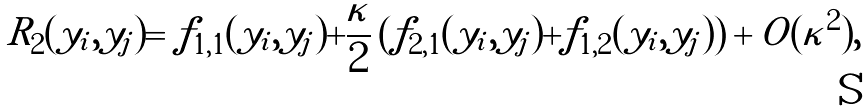Convert formula to latex. <formula><loc_0><loc_0><loc_500><loc_500>R _ { 2 } ( y _ { i } , y _ { j } ) = f _ { 1 , 1 } ( y _ { i } , y _ { j } ) + { \frac { \kappa } { 2 } } \left ( f _ { 2 , 1 } ( y _ { i } , y _ { j } ) + f _ { 1 , 2 } ( y _ { i } , y _ { j } ) \right ) + O ( \kappa ^ { 2 } ) ,</formula> 